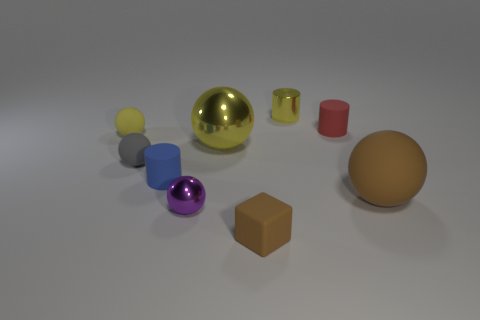There is a blue object; is it the same size as the metal sphere that is in front of the gray object?
Provide a succinct answer. Yes. There is a cylinder in front of the big sphere to the left of the brown cube; are there any rubber cylinders that are in front of it?
Offer a terse response. No. What is the brown object that is on the left side of the metallic cylinder made of?
Your answer should be very brief. Rubber. Do the red matte cylinder and the yellow matte ball have the same size?
Keep it short and to the point. Yes. What is the color of the shiny thing that is both behind the purple object and in front of the small red matte thing?
Offer a terse response. Yellow. The large object that is made of the same material as the yellow cylinder is what shape?
Provide a short and direct response. Sphere. How many shiny things are behind the blue object and in front of the tiny red rubber object?
Your answer should be very brief. 1. Are there any yellow metal cylinders in front of the red cylinder?
Your response must be concise. No. There is a rubber thing on the right side of the small red cylinder; is it the same shape as the red matte object behind the tiny gray matte sphere?
Your response must be concise. No. How many things are either large shiny objects or metallic spheres behind the tiny blue object?
Provide a succinct answer. 1. 